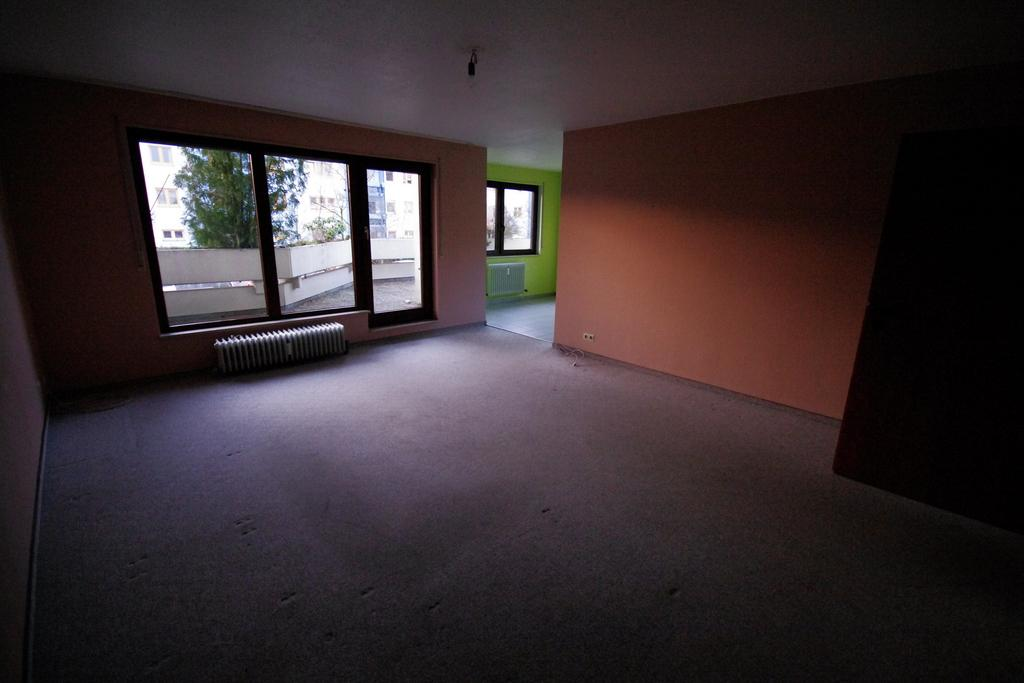What is the main subject of the image? The main subject of the image is a house. How are the walls of the house decorated? The walls of the house are painted in different colors. How many windows are visible on one wall of the house? There are three windows on one wall of the house. What can be seen through the windows? Other buildings and a tree are visible through the windows. What type of feast is being prepared in the house in the image? There is no indication of a feast or any food preparation in the image; it only shows the exterior of the house with painted walls and windows. 